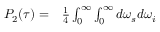Convert formula to latex. <formula><loc_0><loc_0><loc_500><loc_500>\begin{array} { r l } { P _ { 2 } ( \tau ) = } & \frac { 1 } { 4 } \int _ { 0 } ^ { \infty } \int _ { 0 } ^ { \infty } d \omega _ { s } d \omega _ { i } } \end{array}</formula> 